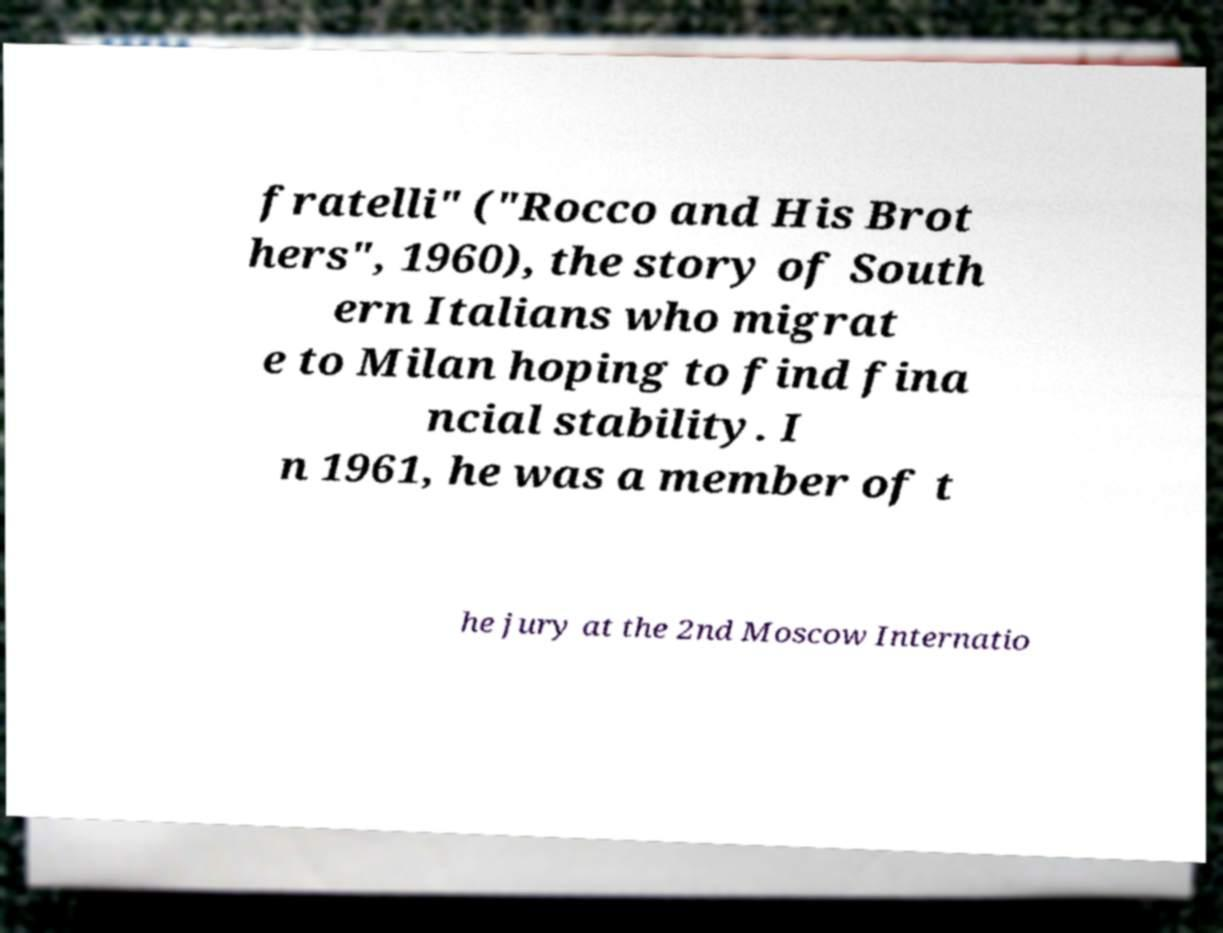Please read and relay the text visible in this image. What does it say? fratelli" ("Rocco and His Brot hers", 1960), the story of South ern Italians who migrat e to Milan hoping to find fina ncial stability. I n 1961, he was a member of t he jury at the 2nd Moscow Internatio 